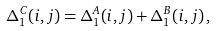<formula> <loc_0><loc_0><loc_500><loc_500>\Delta _ { 1 } ^ { C } ( { i , j } ) = \Delta _ { 1 } ^ { A } ( { i , j } ) + \Delta _ { 1 } ^ { B } ( { i , j } ) \, ,</formula> 